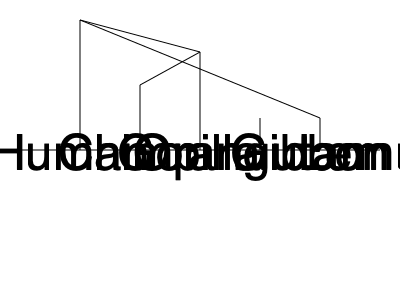Based on the phylogenetic tree shown, which primate species shares the most recent common ancestor with humans, and what does this imply about their genomic similarity? To answer this question, we need to follow these steps:

1. Interpret the phylogenetic tree:
   - The tree represents evolutionary relationships among primates.
   - Species that branch off closer to each other share a more recent common ancestor.

2. Identify the species closest to humans:
   - Looking at the tree, we can see that the branch leading to humans and chimpanzees diverges most recently.
   - This indicates that humans and chimpanzees share the most recent common ancestor among the species shown.

3. Understand the implications for genomic similarity:
   - Species that share a more recent common ancestor typically have more similar genomes.
   - This is because they have had less time to accumulate genetic differences since their divergence.

4. Consider the comparative genomics perspective:
   - As a zoologist specializing in comparative genomics, we know that genomic similarity is often correlated with evolutionary closeness.
   - The close relationship between humans and chimpanzees suggests that their genomes will be more similar to each other than to other primates in the tree.

5. Quantify the similarity:
   - While not shown in the tree, it's worth noting that humans and chimpanzees typically share about 98-99% of their DNA sequences.
   - This high degree of similarity is consistent with their close evolutionary relationship as depicted in the phylogenetic tree.
Answer: Chimpanzees; highest genomic similarity to humans among primates shown. 